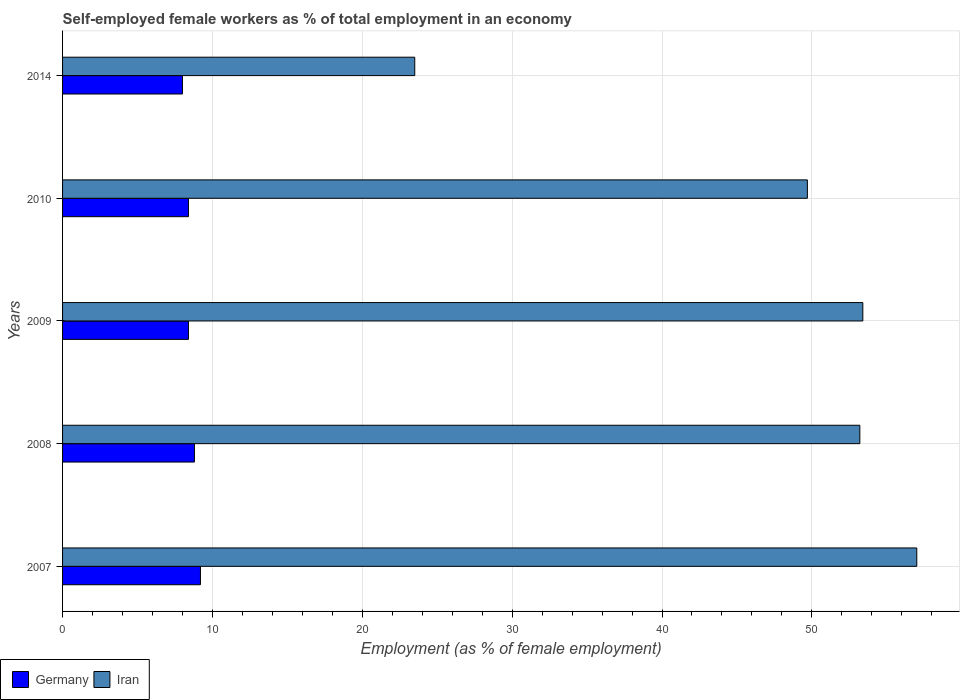How many groups of bars are there?
Make the answer very short. 5. Are the number of bars per tick equal to the number of legend labels?
Your answer should be very brief. Yes. Are the number of bars on each tick of the Y-axis equal?
Provide a short and direct response. Yes. How many bars are there on the 1st tick from the bottom?
Offer a very short reply. 2. What is the label of the 3rd group of bars from the top?
Ensure brevity in your answer.  2009. In how many cases, is the number of bars for a given year not equal to the number of legend labels?
Your response must be concise. 0. Across all years, what is the maximum percentage of self-employed female workers in Iran?
Your response must be concise. 57. In which year was the percentage of self-employed female workers in Iran maximum?
Provide a short and direct response. 2007. In which year was the percentage of self-employed female workers in Iran minimum?
Give a very brief answer. 2014. What is the total percentage of self-employed female workers in Iran in the graph?
Provide a short and direct response. 236.8. What is the difference between the percentage of self-employed female workers in Germany in 2007 and that in 2009?
Make the answer very short. 0.8. What is the difference between the percentage of self-employed female workers in Germany in 2009 and the percentage of self-employed female workers in Iran in 2007?
Give a very brief answer. -48.6. What is the average percentage of self-employed female workers in Iran per year?
Keep it short and to the point. 47.36. In the year 2009, what is the difference between the percentage of self-employed female workers in Iran and percentage of self-employed female workers in Germany?
Your response must be concise. 45. Is the difference between the percentage of self-employed female workers in Iran in 2008 and 2014 greater than the difference between the percentage of self-employed female workers in Germany in 2008 and 2014?
Ensure brevity in your answer.  Yes. What is the difference between the highest and the second highest percentage of self-employed female workers in Germany?
Your response must be concise. 0.4. What is the difference between the highest and the lowest percentage of self-employed female workers in Iran?
Provide a succinct answer. 33.5. Is the sum of the percentage of self-employed female workers in Germany in 2007 and 2009 greater than the maximum percentage of self-employed female workers in Iran across all years?
Offer a terse response. No. What does the 1st bar from the top in 2009 represents?
Provide a short and direct response. Iran. What does the 1st bar from the bottom in 2009 represents?
Provide a succinct answer. Germany. How many bars are there?
Give a very brief answer. 10. How many years are there in the graph?
Offer a terse response. 5. Does the graph contain grids?
Make the answer very short. Yes. How many legend labels are there?
Offer a very short reply. 2. How are the legend labels stacked?
Ensure brevity in your answer.  Horizontal. What is the title of the graph?
Your answer should be very brief. Self-employed female workers as % of total employment in an economy. Does "Libya" appear as one of the legend labels in the graph?
Your answer should be very brief. No. What is the label or title of the X-axis?
Your answer should be very brief. Employment (as % of female employment). What is the Employment (as % of female employment) in Germany in 2007?
Offer a terse response. 9.2. What is the Employment (as % of female employment) of Iran in 2007?
Your answer should be compact. 57. What is the Employment (as % of female employment) in Germany in 2008?
Offer a very short reply. 8.8. What is the Employment (as % of female employment) of Iran in 2008?
Make the answer very short. 53.2. What is the Employment (as % of female employment) of Germany in 2009?
Ensure brevity in your answer.  8.4. What is the Employment (as % of female employment) in Iran in 2009?
Provide a succinct answer. 53.4. What is the Employment (as % of female employment) in Germany in 2010?
Ensure brevity in your answer.  8.4. What is the Employment (as % of female employment) in Iran in 2010?
Make the answer very short. 49.7. What is the Employment (as % of female employment) of Iran in 2014?
Your answer should be very brief. 23.5. Across all years, what is the maximum Employment (as % of female employment) in Germany?
Ensure brevity in your answer.  9.2. Across all years, what is the maximum Employment (as % of female employment) in Iran?
Offer a terse response. 57. Across all years, what is the minimum Employment (as % of female employment) of Germany?
Make the answer very short. 8. Across all years, what is the minimum Employment (as % of female employment) of Iran?
Offer a terse response. 23.5. What is the total Employment (as % of female employment) in Germany in the graph?
Your answer should be compact. 42.8. What is the total Employment (as % of female employment) in Iran in the graph?
Make the answer very short. 236.8. What is the difference between the Employment (as % of female employment) in Germany in 2007 and that in 2008?
Provide a short and direct response. 0.4. What is the difference between the Employment (as % of female employment) of Germany in 2007 and that in 2009?
Your response must be concise. 0.8. What is the difference between the Employment (as % of female employment) in Iran in 2007 and that in 2009?
Your response must be concise. 3.6. What is the difference between the Employment (as % of female employment) in Germany in 2007 and that in 2010?
Provide a short and direct response. 0.8. What is the difference between the Employment (as % of female employment) of Germany in 2007 and that in 2014?
Your response must be concise. 1.2. What is the difference between the Employment (as % of female employment) in Iran in 2007 and that in 2014?
Give a very brief answer. 33.5. What is the difference between the Employment (as % of female employment) in Germany in 2008 and that in 2010?
Ensure brevity in your answer.  0.4. What is the difference between the Employment (as % of female employment) in Iran in 2008 and that in 2014?
Your response must be concise. 29.7. What is the difference between the Employment (as % of female employment) of Iran in 2009 and that in 2010?
Make the answer very short. 3.7. What is the difference between the Employment (as % of female employment) in Iran in 2009 and that in 2014?
Ensure brevity in your answer.  29.9. What is the difference between the Employment (as % of female employment) in Germany in 2010 and that in 2014?
Provide a succinct answer. 0.4. What is the difference between the Employment (as % of female employment) of Iran in 2010 and that in 2014?
Give a very brief answer. 26.2. What is the difference between the Employment (as % of female employment) of Germany in 2007 and the Employment (as % of female employment) of Iran in 2008?
Your response must be concise. -44. What is the difference between the Employment (as % of female employment) of Germany in 2007 and the Employment (as % of female employment) of Iran in 2009?
Provide a short and direct response. -44.2. What is the difference between the Employment (as % of female employment) of Germany in 2007 and the Employment (as % of female employment) of Iran in 2010?
Your response must be concise. -40.5. What is the difference between the Employment (as % of female employment) of Germany in 2007 and the Employment (as % of female employment) of Iran in 2014?
Your answer should be very brief. -14.3. What is the difference between the Employment (as % of female employment) in Germany in 2008 and the Employment (as % of female employment) in Iran in 2009?
Keep it short and to the point. -44.6. What is the difference between the Employment (as % of female employment) of Germany in 2008 and the Employment (as % of female employment) of Iran in 2010?
Offer a very short reply. -40.9. What is the difference between the Employment (as % of female employment) in Germany in 2008 and the Employment (as % of female employment) in Iran in 2014?
Ensure brevity in your answer.  -14.7. What is the difference between the Employment (as % of female employment) in Germany in 2009 and the Employment (as % of female employment) in Iran in 2010?
Ensure brevity in your answer.  -41.3. What is the difference between the Employment (as % of female employment) of Germany in 2009 and the Employment (as % of female employment) of Iran in 2014?
Your response must be concise. -15.1. What is the difference between the Employment (as % of female employment) in Germany in 2010 and the Employment (as % of female employment) in Iran in 2014?
Provide a succinct answer. -15.1. What is the average Employment (as % of female employment) in Germany per year?
Provide a short and direct response. 8.56. What is the average Employment (as % of female employment) in Iran per year?
Keep it short and to the point. 47.36. In the year 2007, what is the difference between the Employment (as % of female employment) of Germany and Employment (as % of female employment) of Iran?
Keep it short and to the point. -47.8. In the year 2008, what is the difference between the Employment (as % of female employment) in Germany and Employment (as % of female employment) in Iran?
Your response must be concise. -44.4. In the year 2009, what is the difference between the Employment (as % of female employment) of Germany and Employment (as % of female employment) of Iran?
Offer a very short reply. -45. In the year 2010, what is the difference between the Employment (as % of female employment) in Germany and Employment (as % of female employment) in Iran?
Your answer should be compact. -41.3. In the year 2014, what is the difference between the Employment (as % of female employment) in Germany and Employment (as % of female employment) in Iran?
Your answer should be very brief. -15.5. What is the ratio of the Employment (as % of female employment) of Germany in 2007 to that in 2008?
Make the answer very short. 1.05. What is the ratio of the Employment (as % of female employment) in Iran in 2007 to that in 2008?
Keep it short and to the point. 1.07. What is the ratio of the Employment (as % of female employment) of Germany in 2007 to that in 2009?
Offer a very short reply. 1.1. What is the ratio of the Employment (as % of female employment) of Iran in 2007 to that in 2009?
Ensure brevity in your answer.  1.07. What is the ratio of the Employment (as % of female employment) in Germany in 2007 to that in 2010?
Your answer should be compact. 1.1. What is the ratio of the Employment (as % of female employment) in Iran in 2007 to that in 2010?
Keep it short and to the point. 1.15. What is the ratio of the Employment (as % of female employment) in Germany in 2007 to that in 2014?
Your answer should be compact. 1.15. What is the ratio of the Employment (as % of female employment) of Iran in 2007 to that in 2014?
Offer a terse response. 2.43. What is the ratio of the Employment (as % of female employment) in Germany in 2008 to that in 2009?
Your response must be concise. 1.05. What is the ratio of the Employment (as % of female employment) in Germany in 2008 to that in 2010?
Offer a terse response. 1.05. What is the ratio of the Employment (as % of female employment) in Iran in 2008 to that in 2010?
Ensure brevity in your answer.  1.07. What is the ratio of the Employment (as % of female employment) in Germany in 2008 to that in 2014?
Keep it short and to the point. 1.1. What is the ratio of the Employment (as % of female employment) of Iran in 2008 to that in 2014?
Offer a terse response. 2.26. What is the ratio of the Employment (as % of female employment) in Germany in 2009 to that in 2010?
Your answer should be very brief. 1. What is the ratio of the Employment (as % of female employment) in Iran in 2009 to that in 2010?
Your answer should be very brief. 1.07. What is the ratio of the Employment (as % of female employment) of Germany in 2009 to that in 2014?
Your answer should be compact. 1.05. What is the ratio of the Employment (as % of female employment) of Iran in 2009 to that in 2014?
Ensure brevity in your answer.  2.27. What is the ratio of the Employment (as % of female employment) of Germany in 2010 to that in 2014?
Provide a succinct answer. 1.05. What is the ratio of the Employment (as % of female employment) of Iran in 2010 to that in 2014?
Your response must be concise. 2.11. What is the difference between the highest and the second highest Employment (as % of female employment) of Iran?
Give a very brief answer. 3.6. What is the difference between the highest and the lowest Employment (as % of female employment) of Germany?
Make the answer very short. 1.2. What is the difference between the highest and the lowest Employment (as % of female employment) of Iran?
Keep it short and to the point. 33.5. 